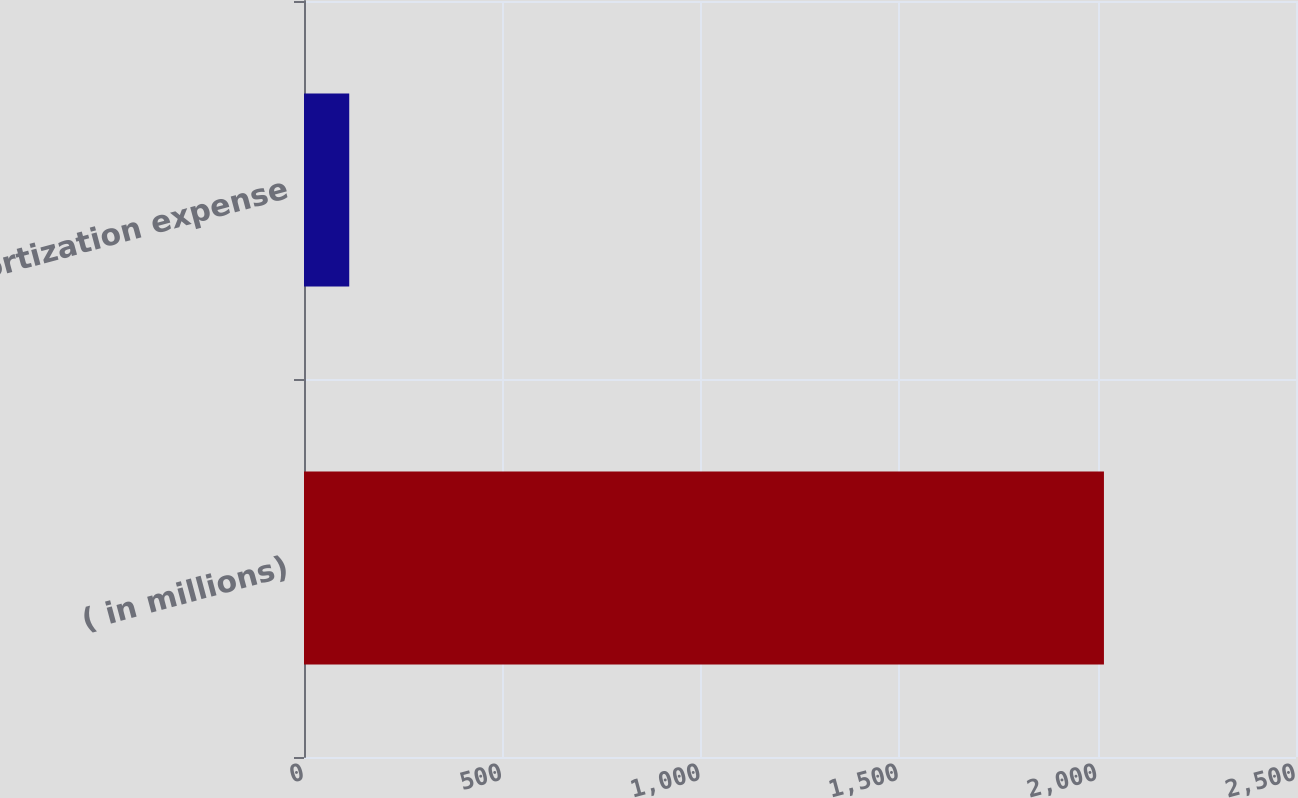Convert chart. <chart><loc_0><loc_0><loc_500><loc_500><bar_chart><fcel>( in millions)<fcel>Amortization expense<nl><fcel>2016<fcel>114<nl></chart> 